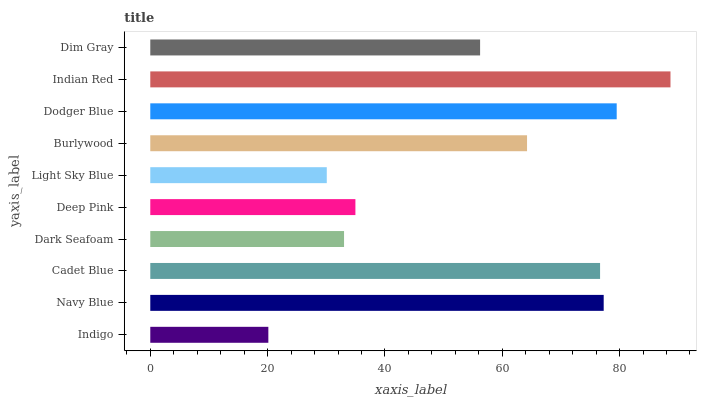Is Indigo the minimum?
Answer yes or no. Yes. Is Indian Red the maximum?
Answer yes or no. Yes. Is Navy Blue the minimum?
Answer yes or no. No. Is Navy Blue the maximum?
Answer yes or no. No. Is Navy Blue greater than Indigo?
Answer yes or no. Yes. Is Indigo less than Navy Blue?
Answer yes or no. Yes. Is Indigo greater than Navy Blue?
Answer yes or no. No. Is Navy Blue less than Indigo?
Answer yes or no. No. Is Burlywood the high median?
Answer yes or no. Yes. Is Dim Gray the low median?
Answer yes or no. Yes. Is Dim Gray the high median?
Answer yes or no. No. Is Burlywood the low median?
Answer yes or no. No. 